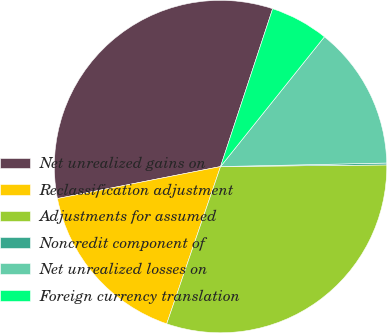Convert chart to OTSL. <chart><loc_0><loc_0><loc_500><loc_500><pie_chart><fcel>Net unrealized gains on<fcel>Reclassification adjustment<fcel>Adjustments for assumed<fcel>Noncredit component of<fcel>Net unrealized losses on<fcel>Foreign currency translation<nl><fcel>33.16%<fcel>16.67%<fcel>30.41%<fcel>0.18%<fcel>13.92%<fcel>5.67%<nl></chart> 